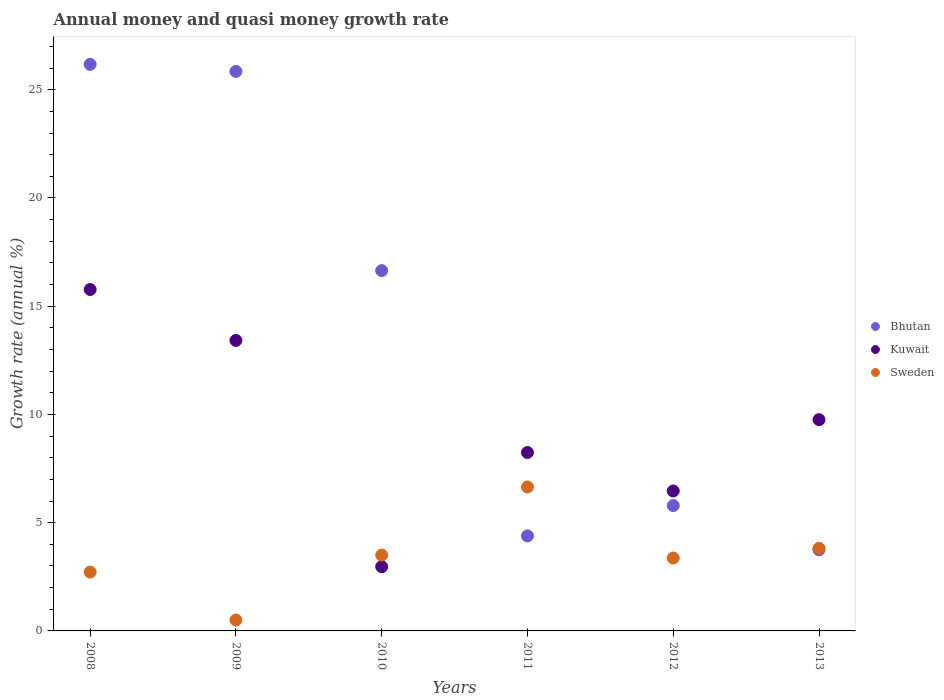How many different coloured dotlines are there?
Provide a short and direct response. 3. What is the growth rate in Kuwait in 2011?
Make the answer very short. 8.24. Across all years, what is the maximum growth rate in Kuwait?
Offer a very short reply. 15.77. Across all years, what is the minimum growth rate in Sweden?
Provide a succinct answer. 0.51. In which year was the growth rate in Bhutan minimum?
Keep it short and to the point. 2013. What is the total growth rate in Kuwait in the graph?
Give a very brief answer. 56.62. What is the difference between the growth rate in Sweden in 2010 and that in 2011?
Give a very brief answer. -3.15. What is the difference between the growth rate in Sweden in 2012 and the growth rate in Bhutan in 2009?
Ensure brevity in your answer.  -22.48. What is the average growth rate in Bhutan per year?
Provide a short and direct response. 13.76. In the year 2011, what is the difference between the growth rate in Kuwait and growth rate in Bhutan?
Your answer should be compact. 3.85. In how many years, is the growth rate in Kuwait greater than 9 %?
Provide a short and direct response. 3. What is the ratio of the growth rate in Bhutan in 2010 to that in 2013?
Make the answer very short. 4.44. What is the difference between the highest and the second highest growth rate in Bhutan?
Ensure brevity in your answer.  0.33. What is the difference between the highest and the lowest growth rate in Sweden?
Your response must be concise. 6.14. In how many years, is the growth rate in Sweden greater than the average growth rate in Sweden taken over all years?
Offer a very short reply. 3. Is the growth rate in Kuwait strictly less than the growth rate in Sweden over the years?
Give a very brief answer. No. What is the difference between two consecutive major ticks on the Y-axis?
Your response must be concise. 5. Are the values on the major ticks of Y-axis written in scientific E-notation?
Your answer should be compact. No. Does the graph contain any zero values?
Offer a terse response. No. Does the graph contain grids?
Provide a succinct answer. No. Where does the legend appear in the graph?
Give a very brief answer. Center right. How are the legend labels stacked?
Your response must be concise. Vertical. What is the title of the graph?
Your answer should be very brief. Annual money and quasi money growth rate. Does "Lebanon" appear as one of the legend labels in the graph?
Your answer should be compact. No. What is the label or title of the X-axis?
Give a very brief answer. Years. What is the label or title of the Y-axis?
Ensure brevity in your answer.  Growth rate (annual %). What is the Growth rate (annual %) of Bhutan in 2008?
Provide a succinct answer. 26.17. What is the Growth rate (annual %) in Kuwait in 2008?
Provide a succinct answer. 15.77. What is the Growth rate (annual %) in Sweden in 2008?
Your answer should be very brief. 2.72. What is the Growth rate (annual %) of Bhutan in 2009?
Offer a very short reply. 25.84. What is the Growth rate (annual %) in Kuwait in 2009?
Your answer should be compact. 13.42. What is the Growth rate (annual %) in Sweden in 2009?
Your response must be concise. 0.51. What is the Growth rate (annual %) of Bhutan in 2010?
Offer a terse response. 16.64. What is the Growth rate (annual %) in Kuwait in 2010?
Your answer should be compact. 2.97. What is the Growth rate (annual %) in Sweden in 2010?
Your answer should be compact. 3.5. What is the Growth rate (annual %) of Bhutan in 2011?
Ensure brevity in your answer.  4.39. What is the Growth rate (annual %) of Kuwait in 2011?
Your answer should be very brief. 8.24. What is the Growth rate (annual %) of Sweden in 2011?
Your response must be concise. 6.65. What is the Growth rate (annual %) of Bhutan in 2012?
Ensure brevity in your answer.  5.79. What is the Growth rate (annual %) of Kuwait in 2012?
Provide a short and direct response. 6.47. What is the Growth rate (annual %) in Sweden in 2012?
Ensure brevity in your answer.  3.37. What is the Growth rate (annual %) in Bhutan in 2013?
Your answer should be compact. 3.75. What is the Growth rate (annual %) of Kuwait in 2013?
Your answer should be very brief. 9.76. What is the Growth rate (annual %) in Sweden in 2013?
Your answer should be very brief. 3.82. Across all years, what is the maximum Growth rate (annual %) of Bhutan?
Provide a short and direct response. 26.17. Across all years, what is the maximum Growth rate (annual %) of Kuwait?
Offer a terse response. 15.77. Across all years, what is the maximum Growth rate (annual %) in Sweden?
Ensure brevity in your answer.  6.65. Across all years, what is the minimum Growth rate (annual %) of Bhutan?
Keep it short and to the point. 3.75. Across all years, what is the minimum Growth rate (annual %) of Kuwait?
Your answer should be very brief. 2.97. Across all years, what is the minimum Growth rate (annual %) of Sweden?
Provide a short and direct response. 0.51. What is the total Growth rate (annual %) in Bhutan in the graph?
Provide a succinct answer. 82.58. What is the total Growth rate (annual %) in Kuwait in the graph?
Ensure brevity in your answer.  56.62. What is the total Growth rate (annual %) of Sweden in the graph?
Your answer should be very brief. 20.56. What is the difference between the Growth rate (annual %) of Bhutan in 2008 and that in 2009?
Make the answer very short. 0.33. What is the difference between the Growth rate (annual %) of Kuwait in 2008 and that in 2009?
Ensure brevity in your answer.  2.35. What is the difference between the Growth rate (annual %) in Sweden in 2008 and that in 2009?
Offer a very short reply. 2.21. What is the difference between the Growth rate (annual %) of Bhutan in 2008 and that in 2010?
Your answer should be compact. 9.53. What is the difference between the Growth rate (annual %) of Kuwait in 2008 and that in 2010?
Ensure brevity in your answer.  12.81. What is the difference between the Growth rate (annual %) in Sweden in 2008 and that in 2010?
Provide a succinct answer. -0.78. What is the difference between the Growth rate (annual %) in Bhutan in 2008 and that in 2011?
Offer a very short reply. 21.78. What is the difference between the Growth rate (annual %) in Kuwait in 2008 and that in 2011?
Give a very brief answer. 7.53. What is the difference between the Growth rate (annual %) of Sweden in 2008 and that in 2011?
Keep it short and to the point. -3.93. What is the difference between the Growth rate (annual %) in Bhutan in 2008 and that in 2012?
Your answer should be very brief. 20.38. What is the difference between the Growth rate (annual %) of Kuwait in 2008 and that in 2012?
Ensure brevity in your answer.  9.31. What is the difference between the Growth rate (annual %) in Sweden in 2008 and that in 2012?
Make the answer very short. -0.65. What is the difference between the Growth rate (annual %) in Bhutan in 2008 and that in 2013?
Ensure brevity in your answer.  22.42. What is the difference between the Growth rate (annual %) of Kuwait in 2008 and that in 2013?
Keep it short and to the point. 6.01. What is the difference between the Growth rate (annual %) in Sweden in 2008 and that in 2013?
Your answer should be compact. -1.1. What is the difference between the Growth rate (annual %) in Bhutan in 2009 and that in 2010?
Your answer should be very brief. 9.2. What is the difference between the Growth rate (annual %) of Kuwait in 2009 and that in 2010?
Keep it short and to the point. 10.45. What is the difference between the Growth rate (annual %) in Sweden in 2009 and that in 2010?
Offer a terse response. -3. What is the difference between the Growth rate (annual %) of Bhutan in 2009 and that in 2011?
Ensure brevity in your answer.  21.46. What is the difference between the Growth rate (annual %) in Kuwait in 2009 and that in 2011?
Give a very brief answer. 5.18. What is the difference between the Growth rate (annual %) in Sweden in 2009 and that in 2011?
Offer a terse response. -6.14. What is the difference between the Growth rate (annual %) in Bhutan in 2009 and that in 2012?
Offer a terse response. 20.05. What is the difference between the Growth rate (annual %) of Kuwait in 2009 and that in 2012?
Provide a short and direct response. 6.95. What is the difference between the Growth rate (annual %) in Sweden in 2009 and that in 2012?
Your answer should be very brief. -2.86. What is the difference between the Growth rate (annual %) in Bhutan in 2009 and that in 2013?
Make the answer very short. 22.1. What is the difference between the Growth rate (annual %) of Kuwait in 2009 and that in 2013?
Offer a very short reply. 3.66. What is the difference between the Growth rate (annual %) in Sweden in 2009 and that in 2013?
Your answer should be compact. -3.31. What is the difference between the Growth rate (annual %) of Bhutan in 2010 and that in 2011?
Keep it short and to the point. 12.26. What is the difference between the Growth rate (annual %) in Kuwait in 2010 and that in 2011?
Give a very brief answer. -5.27. What is the difference between the Growth rate (annual %) of Sweden in 2010 and that in 2011?
Your answer should be very brief. -3.15. What is the difference between the Growth rate (annual %) of Bhutan in 2010 and that in 2012?
Keep it short and to the point. 10.85. What is the difference between the Growth rate (annual %) in Kuwait in 2010 and that in 2012?
Offer a very short reply. -3.5. What is the difference between the Growth rate (annual %) of Sweden in 2010 and that in 2012?
Provide a succinct answer. 0.13. What is the difference between the Growth rate (annual %) in Bhutan in 2010 and that in 2013?
Keep it short and to the point. 12.9. What is the difference between the Growth rate (annual %) in Kuwait in 2010 and that in 2013?
Your response must be concise. -6.79. What is the difference between the Growth rate (annual %) in Sweden in 2010 and that in 2013?
Provide a succinct answer. -0.31. What is the difference between the Growth rate (annual %) of Bhutan in 2011 and that in 2012?
Your response must be concise. -1.4. What is the difference between the Growth rate (annual %) in Kuwait in 2011 and that in 2012?
Ensure brevity in your answer.  1.77. What is the difference between the Growth rate (annual %) in Sweden in 2011 and that in 2012?
Your answer should be compact. 3.28. What is the difference between the Growth rate (annual %) of Bhutan in 2011 and that in 2013?
Keep it short and to the point. 0.64. What is the difference between the Growth rate (annual %) in Kuwait in 2011 and that in 2013?
Offer a very short reply. -1.52. What is the difference between the Growth rate (annual %) of Sweden in 2011 and that in 2013?
Your answer should be compact. 2.83. What is the difference between the Growth rate (annual %) in Bhutan in 2012 and that in 2013?
Offer a very short reply. 2.04. What is the difference between the Growth rate (annual %) in Kuwait in 2012 and that in 2013?
Provide a short and direct response. -3.29. What is the difference between the Growth rate (annual %) in Sweden in 2012 and that in 2013?
Provide a short and direct response. -0.45. What is the difference between the Growth rate (annual %) of Bhutan in 2008 and the Growth rate (annual %) of Kuwait in 2009?
Ensure brevity in your answer.  12.75. What is the difference between the Growth rate (annual %) of Bhutan in 2008 and the Growth rate (annual %) of Sweden in 2009?
Ensure brevity in your answer.  25.67. What is the difference between the Growth rate (annual %) of Kuwait in 2008 and the Growth rate (annual %) of Sweden in 2009?
Your answer should be compact. 15.27. What is the difference between the Growth rate (annual %) in Bhutan in 2008 and the Growth rate (annual %) in Kuwait in 2010?
Your answer should be compact. 23.2. What is the difference between the Growth rate (annual %) of Bhutan in 2008 and the Growth rate (annual %) of Sweden in 2010?
Offer a very short reply. 22.67. What is the difference between the Growth rate (annual %) of Kuwait in 2008 and the Growth rate (annual %) of Sweden in 2010?
Make the answer very short. 12.27. What is the difference between the Growth rate (annual %) in Bhutan in 2008 and the Growth rate (annual %) in Kuwait in 2011?
Make the answer very short. 17.93. What is the difference between the Growth rate (annual %) of Bhutan in 2008 and the Growth rate (annual %) of Sweden in 2011?
Provide a short and direct response. 19.52. What is the difference between the Growth rate (annual %) of Kuwait in 2008 and the Growth rate (annual %) of Sweden in 2011?
Make the answer very short. 9.12. What is the difference between the Growth rate (annual %) of Bhutan in 2008 and the Growth rate (annual %) of Kuwait in 2012?
Offer a very short reply. 19.71. What is the difference between the Growth rate (annual %) in Bhutan in 2008 and the Growth rate (annual %) in Sweden in 2012?
Your answer should be compact. 22.8. What is the difference between the Growth rate (annual %) of Kuwait in 2008 and the Growth rate (annual %) of Sweden in 2012?
Provide a succinct answer. 12.4. What is the difference between the Growth rate (annual %) of Bhutan in 2008 and the Growth rate (annual %) of Kuwait in 2013?
Your answer should be very brief. 16.41. What is the difference between the Growth rate (annual %) of Bhutan in 2008 and the Growth rate (annual %) of Sweden in 2013?
Your answer should be very brief. 22.36. What is the difference between the Growth rate (annual %) in Kuwait in 2008 and the Growth rate (annual %) in Sweden in 2013?
Provide a succinct answer. 11.96. What is the difference between the Growth rate (annual %) in Bhutan in 2009 and the Growth rate (annual %) in Kuwait in 2010?
Your answer should be compact. 22.88. What is the difference between the Growth rate (annual %) of Bhutan in 2009 and the Growth rate (annual %) of Sweden in 2010?
Provide a succinct answer. 22.34. What is the difference between the Growth rate (annual %) of Kuwait in 2009 and the Growth rate (annual %) of Sweden in 2010?
Your answer should be compact. 9.92. What is the difference between the Growth rate (annual %) of Bhutan in 2009 and the Growth rate (annual %) of Kuwait in 2011?
Your response must be concise. 17.6. What is the difference between the Growth rate (annual %) of Bhutan in 2009 and the Growth rate (annual %) of Sweden in 2011?
Your answer should be compact. 19.2. What is the difference between the Growth rate (annual %) in Kuwait in 2009 and the Growth rate (annual %) in Sweden in 2011?
Provide a succinct answer. 6.77. What is the difference between the Growth rate (annual %) of Bhutan in 2009 and the Growth rate (annual %) of Kuwait in 2012?
Give a very brief answer. 19.38. What is the difference between the Growth rate (annual %) of Bhutan in 2009 and the Growth rate (annual %) of Sweden in 2012?
Your response must be concise. 22.48. What is the difference between the Growth rate (annual %) of Kuwait in 2009 and the Growth rate (annual %) of Sweden in 2012?
Your answer should be compact. 10.05. What is the difference between the Growth rate (annual %) of Bhutan in 2009 and the Growth rate (annual %) of Kuwait in 2013?
Ensure brevity in your answer.  16.09. What is the difference between the Growth rate (annual %) in Bhutan in 2009 and the Growth rate (annual %) in Sweden in 2013?
Provide a short and direct response. 22.03. What is the difference between the Growth rate (annual %) of Kuwait in 2009 and the Growth rate (annual %) of Sweden in 2013?
Make the answer very short. 9.6. What is the difference between the Growth rate (annual %) of Bhutan in 2010 and the Growth rate (annual %) of Kuwait in 2011?
Provide a succinct answer. 8.4. What is the difference between the Growth rate (annual %) in Bhutan in 2010 and the Growth rate (annual %) in Sweden in 2011?
Your response must be concise. 10. What is the difference between the Growth rate (annual %) in Kuwait in 2010 and the Growth rate (annual %) in Sweden in 2011?
Make the answer very short. -3.68. What is the difference between the Growth rate (annual %) of Bhutan in 2010 and the Growth rate (annual %) of Kuwait in 2012?
Offer a terse response. 10.18. What is the difference between the Growth rate (annual %) of Bhutan in 2010 and the Growth rate (annual %) of Sweden in 2012?
Your answer should be very brief. 13.27. What is the difference between the Growth rate (annual %) of Kuwait in 2010 and the Growth rate (annual %) of Sweden in 2012?
Your answer should be very brief. -0.4. What is the difference between the Growth rate (annual %) in Bhutan in 2010 and the Growth rate (annual %) in Kuwait in 2013?
Provide a short and direct response. 6.88. What is the difference between the Growth rate (annual %) of Bhutan in 2010 and the Growth rate (annual %) of Sweden in 2013?
Keep it short and to the point. 12.83. What is the difference between the Growth rate (annual %) in Kuwait in 2010 and the Growth rate (annual %) in Sweden in 2013?
Ensure brevity in your answer.  -0.85. What is the difference between the Growth rate (annual %) of Bhutan in 2011 and the Growth rate (annual %) of Kuwait in 2012?
Your answer should be compact. -2.08. What is the difference between the Growth rate (annual %) of Bhutan in 2011 and the Growth rate (annual %) of Sweden in 2012?
Offer a very short reply. 1.02. What is the difference between the Growth rate (annual %) of Kuwait in 2011 and the Growth rate (annual %) of Sweden in 2012?
Provide a succinct answer. 4.87. What is the difference between the Growth rate (annual %) in Bhutan in 2011 and the Growth rate (annual %) in Kuwait in 2013?
Offer a terse response. -5.37. What is the difference between the Growth rate (annual %) of Bhutan in 2011 and the Growth rate (annual %) of Sweden in 2013?
Give a very brief answer. 0.57. What is the difference between the Growth rate (annual %) of Kuwait in 2011 and the Growth rate (annual %) of Sweden in 2013?
Make the answer very short. 4.43. What is the difference between the Growth rate (annual %) in Bhutan in 2012 and the Growth rate (annual %) in Kuwait in 2013?
Offer a very short reply. -3.97. What is the difference between the Growth rate (annual %) of Bhutan in 2012 and the Growth rate (annual %) of Sweden in 2013?
Your response must be concise. 1.97. What is the difference between the Growth rate (annual %) in Kuwait in 2012 and the Growth rate (annual %) in Sweden in 2013?
Make the answer very short. 2.65. What is the average Growth rate (annual %) of Bhutan per year?
Your answer should be very brief. 13.76. What is the average Growth rate (annual %) in Kuwait per year?
Your answer should be very brief. 9.44. What is the average Growth rate (annual %) in Sweden per year?
Offer a terse response. 3.43. In the year 2008, what is the difference between the Growth rate (annual %) in Bhutan and Growth rate (annual %) in Kuwait?
Provide a short and direct response. 10.4. In the year 2008, what is the difference between the Growth rate (annual %) in Bhutan and Growth rate (annual %) in Sweden?
Make the answer very short. 23.45. In the year 2008, what is the difference between the Growth rate (annual %) of Kuwait and Growth rate (annual %) of Sweden?
Give a very brief answer. 13.05. In the year 2009, what is the difference between the Growth rate (annual %) of Bhutan and Growth rate (annual %) of Kuwait?
Provide a succinct answer. 12.43. In the year 2009, what is the difference between the Growth rate (annual %) in Bhutan and Growth rate (annual %) in Sweden?
Keep it short and to the point. 25.34. In the year 2009, what is the difference between the Growth rate (annual %) in Kuwait and Growth rate (annual %) in Sweden?
Provide a short and direct response. 12.91. In the year 2010, what is the difference between the Growth rate (annual %) of Bhutan and Growth rate (annual %) of Kuwait?
Offer a very short reply. 13.68. In the year 2010, what is the difference between the Growth rate (annual %) in Bhutan and Growth rate (annual %) in Sweden?
Your answer should be compact. 13.14. In the year 2010, what is the difference between the Growth rate (annual %) of Kuwait and Growth rate (annual %) of Sweden?
Your answer should be very brief. -0.54. In the year 2011, what is the difference between the Growth rate (annual %) of Bhutan and Growth rate (annual %) of Kuwait?
Offer a terse response. -3.85. In the year 2011, what is the difference between the Growth rate (annual %) in Bhutan and Growth rate (annual %) in Sweden?
Your answer should be compact. -2.26. In the year 2011, what is the difference between the Growth rate (annual %) of Kuwait and Growth rate (annual %) of Sweden?
Your answer should be compact. 1.59. In the year 2012, what is the difference between the Growth rate (annual %) of Bhutan and Growth rate (annual %) of Kuwait?
Ensure brevity in your answer.  -0.68. In the year 2012, what is the difference between the Growth rate (annual %) in Bhutan and Growth rate (annual %) in Sweden?
Your answer should be very brief. 2.42. In the year 2012, what is the difference between the Growth rate (annual %) of Kuwait and Growth rate (annual %) of Sweden?
Provide a short and direct response. 3.1. In the year 2013, what is the difference between the Growth rate (annual %) in Bhutan and Growth rate (annual %) in Kuwait?
Make the answer very short. -6.01. In the year 2013, what is the difference between the Growth rate (annual %) in Bhutan and Growth rate (annual %) in Sweden?
Offer a terse response. -0.07. In the year 2013, what is the difference between the Growth rate (annual %) in Kuwait and Growth rate (annual %) in Sweden?
Your response must be concise. 5.94. What is the ratio of the Growth rate (annual %) in Bhutan in 2008 to that in 2009?
Make the answer very short. 1.01. What is the ratio of the Growth rate (annual %) in Kuwait in 2008 to that in 2009?
Ensure brevity in your answer.  1.18. What is the ratio of the Growth rate (annual %) of Sweden in 2008 to that in 2009?
Give a very brief answer. 5.38. What is the ratio of the Growth rate (annual %) of Bhutan in 2008 to that in 2010?
Your answer should be compact. 1.57. What is the ratio of the Growth rate (annual %) of Kuwait in 2008 to that in 2010?
Give a very brief answer. 5.32. What is the ratio of the Growth rate (annual %) in Sweden in 2008 to that in 2010?
Provide a succinct answer. 0.78. What is the ratio of the Growth rate (annual %) in Bhutan in 2008 to that in 2011?
Your answer should be compact. 5.96. What is the ratio of the Growth rate (annual %) in Kuwait in 2008 to that in 2011?
Offer a terse response. 1.91. What is the ratio of the Growth rate (annual %) of Sweden in 2008 to that in 2011?
Your answer should be compact. 0.41. What is the ratio of the Growth rate (annual %) in Bhutan in 2008 to that in 2012?
Offer a terse response. 4.52. What is the ratio of the Growth rate (annual %) of Kuwait in 2008 to that in 2012?
Offer a very short reply. 2.44. What is the ratio of the Growth rate (annual %) in Sweden in 2008 to that in 2012?
Provide a succinct answer. 0.81. What is the ratio of the Growth rate (annual %) in Bhutan in 2008 to that in 2013?
Provide a succinct answer. 6.99. What is the ratio of the Growth rate (annual %) of Kuwait in 2008 to that in 2013?
Ensure brevity in your answer.  1.62. What is the ratio of the Growth rate (annual %) of Sweden in 2008 to that in 2013?
Provide a short and direct response. 0.71. What is the ratio of the Growth rate (annual %) of Bhutan in 2009 to that in 2010?
Provide a succinct answer. 1.55. What is the ratio of the Growth rate (annual %) of Kuwait in 2009 to that in 2010?
Ensure brevity in your answer.  4.52. What is the ratio of the Growth rate (annual %) in Sweden in 2009 to that in 2010?
Make the answer very short. 0.14. What is the ratio of the Growth rate (annual %) of Bhutan in 2009 to that in 2011?
Keep it short and to the point. 5.89. What is the ratio of the Growth rate (annual %) of Kuwait in 2009 to that in 2011?
Keep it short and to the point. 1.63. What is the ratio of the Growth rate (annual %) of Sweden in 2009 to that in 2011?
Make the answer very short. 0.08. What is the ratio of the Growth rate (annual %) of Bhutan in 2009 to that in 2012?
Your response must be concise. 4.46. What is the ratio of the Growth rate (annual %) of Kuwait in 2009 to that in 2012?
Provide a short and direct response. 2.08. What is the ratio of the Growth rate (annual %) of Sweden in 2009 to that in 2012?
Your answer should be very brief. 0.15. What is the ratio of the Growth rate (annual %) in Bhutan in 2009 to that in 2013?
Provide a short and direct response. 6.9. What is the ratio of the Growth rate (annual %) in Kuwait in 2009 to that in 2013?
Make the answer very short. 1.38. What is the ratio of the Growth rate (annual %) of Sweden in 2009 to that in 2013?
Your answer should be very brief. 0.13. What is the ratio of the Growth rate (annual %) of Bhutan in 2010 to that in 2011?
Make the answer very short. 3.79. What is the ratio of the Growth rate (annual %) in Kuwait in 2010 to that in 2011?
Provide a succinct answer. 0.36. What is the ratio of the Growth rate (annual %) in Sweden in 2010 to that in 2011?
Give a very brief answer. 0.53. What is the ratio of the Growth rate (annual %) in Bhutan in 2010 to that in 2012?
Give a very brief answer. 2.87. What is the ratio of the Growth rate (annual %) of Kuwait in 2010 to that in 2012?
Make the answer very short. 0.46. What is the ratio of the Growth rate (annual %) of Sweden in 2010 to that in 2012?
Your answer should be compact. 1.04. What is the ratio of the Growth rate (annual %) in Bhutan in 2010 to that in 2013?
Your response must be concise. 4.44. What is the ratio of the Growth rate (annual %) of Kuwait in 2010 to that in 2013?
Provide a short and direct response. 0.3. What is the ratio of the Growth rate (annual %) of Sweden in 2010 to that in 2013?
Offer a very short reply. 0.92. What is the ratio of the Growth rate (annual %) in Bhutan in 2011 to that in 2012?
Offer a terse response. 0.76. What is the ratio of the Growth rate (annual %) of Kuwait in 2011 to that in 2012?
Give a very brief answer. 1.27. What is the ratio of the Growth rate (annual %) of Sweden in 2011 to that in 2012?
Ensure brevity in your answer.  1.97. What is the ratio of the Growth rate (annual %) of Bhutan in 2011 to that in 2013?
Your answer should be very brief. 1.17. What is the ratio of the Growth rate (annual %) of Kuwait in 2011 to that in 2013?
Provide a short and direct response. 0.84. What is the ratio of the Growth rate (annual %) in Sweden in 2011 to that in 2013?
Offer a terse response. 1.74. What is the ratio of the Growth rate (annual %) of Bhutan in 2012 to that in 2013?
Make the answer very short. 1.55. What is the ratio of the Growth rate (annual %) of Kuwait in 2012 to that in 2013?
Provide a succinct answer. 0.66. What is the ratio of the Growth rate (annual %) in Sweden in 2012 to that in 2013?
Your answer should be compact. 0.88. What is the difference between the highest and the second highest Growth rate (annual %) in Bhutan?
Your answer should be very brief. 0.33. What is the difference between the highest and the second highest Growth rate (annual %) in Kuwait?
Make the answer very short. 2.35. What is the difference between the highest and the second highest Growth rate (annual %) of Sweden?
Offer a very short reply. 2.83. What is the difference between the highest and the lowest Growth rate (annual %) of Bhutan?
Make the answer very short. 22.42. What is the difference between the highest and the lowest Growth rate (annual %) in Kuwait?
Ensure brevity in your answer.  12.81. What is the difference between the highest and the lowest Growth rate (annual %) of Sweden?
Make the answer very short. 6.14. 